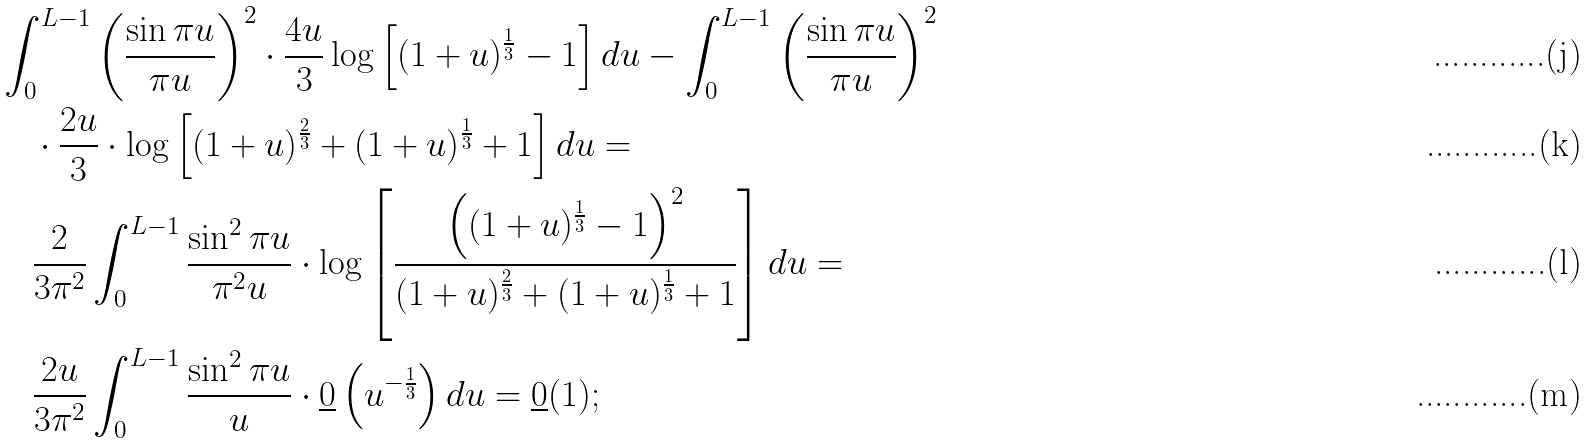<formula> <loc_0><loc_0><loc_500><loc_500>& \int ^ { L - 1 } _ { 0 } \left ( \frac { \sin \pi u } { \pi u } \right ) ^ { 2 } \cdot \frac { 4 u } { 3 } \log \left [ ( 1 + u ) ^ { \frac { 1 } { 3 } } - 1 \right ] d u - \int ^ { L - 1 } _ { 0 } \left ( \frac { \sin \pi u } { \pi u } \right ) ^ { 2 } \\ & \quad \cdot \frac { 2 u } { 3 } \cdot \log \left [ ( 1 + u ) ^ { \frac { 2 } { 3 } } + ( 1 + u ) ^ { \frac { 1 } { 3 } } + 1 \right ] d u = \\ & \quad \frac { 2 } { 3 \pi ^ { 2 } } \int ^ { L - 1 } _ { 0 } \frac { \sin ^ { 2 } \pi u } { \pi ^ { 2 } u } \cdot \log \left [ \frac { \left ( ( 1 + u ) ^ { \frac { 1 } { 3 } } - 1 \right ) ^ { 2 } } { ( 1 + u ) ^ { \frac { 2 } { 3 } } + ( 1 + u ) ^ { \frac { 1 } { 3 } } + 1 } \right ] d u = \\ & \quad \frac { 2 u } { 3 \pi ^ { 2 } } \int ^ { L - 1 } _ { 0 } \frac { \sin ^ { 2 } \pi u } { u } \cdot \underline { 0 } \left ( u ^ { - \frac { 1 } { 3 } } \right ) d u = \underline { 0 } ( 1 ) ;</formula> 